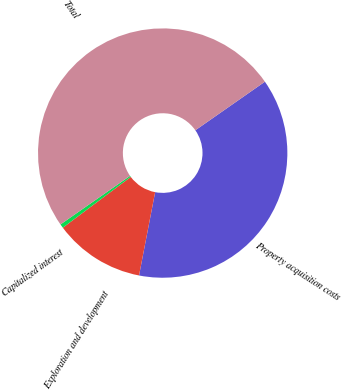<chart> <loc_0><loc_0><loc_500><loc_500><pie_chart><fcel>Property acquisition costs<fcel>Exploration and development<fcel>Capitalized interest<fcel>Total<nl><fcel>37.74%<fcel>11.75%<fcel>0.51%<fcel>50.0%<nl></chart> 